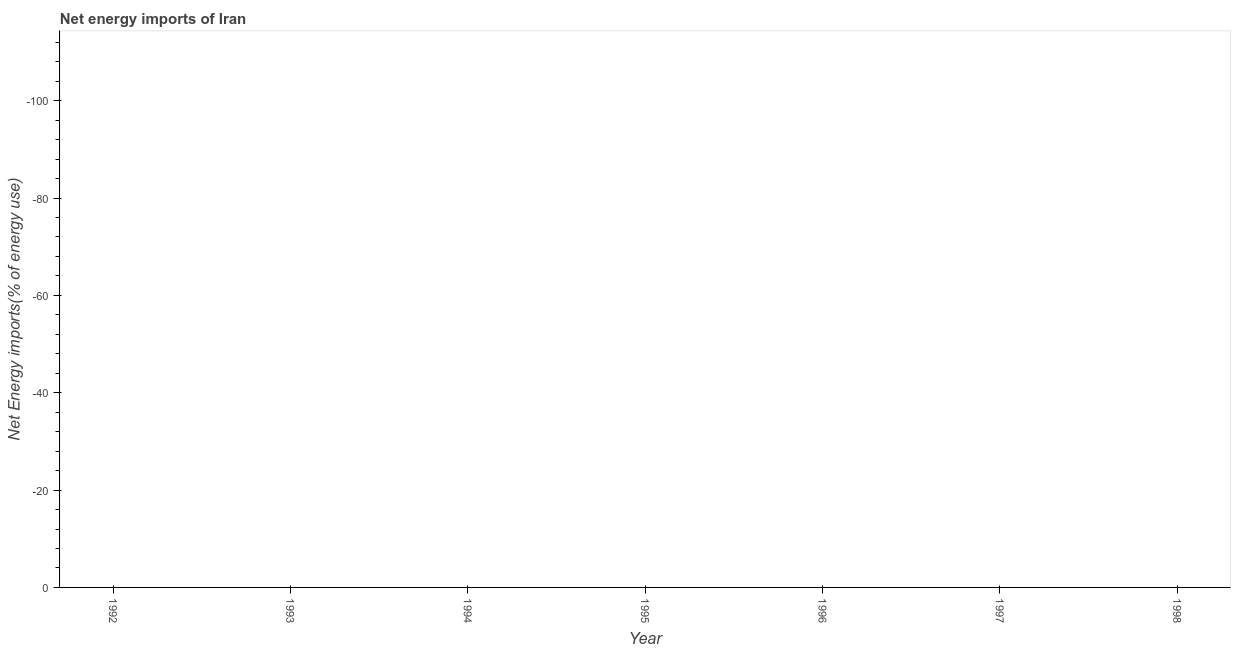What is the energy imports in 1998?
Offer a terse response. 0. What is the average energy imports per year?
Your answer should be compact. 0. In how many years, is the energy imports greater than the average energy imports taken over all years?
Ensure brevity in your answer.  0. What is the difference between two consecutive major ticks on the Y-axis?
Provide a succinct answer. 20. Does the graph contain any zero values?
Provide a short and direct response. Yes. What is the title of the graph?
Offer a very short reply. Net energy imports of Iran. What is the label or title of the X-axis?
Offer a very short reply. Year. What is the label or title of the Y-axis?
Give a very brief answer. Net Energy imports(% of energy use). What is the Net Energy imports(% of energy use) in 1994?
Your response must be concise. 0. What is the Net Energy imports(% of energy use) in 1995?
Offer a terse response. 0. What is the Net Energy imports(% of energy use) in 1998?
Your answer should be compact. 0. 